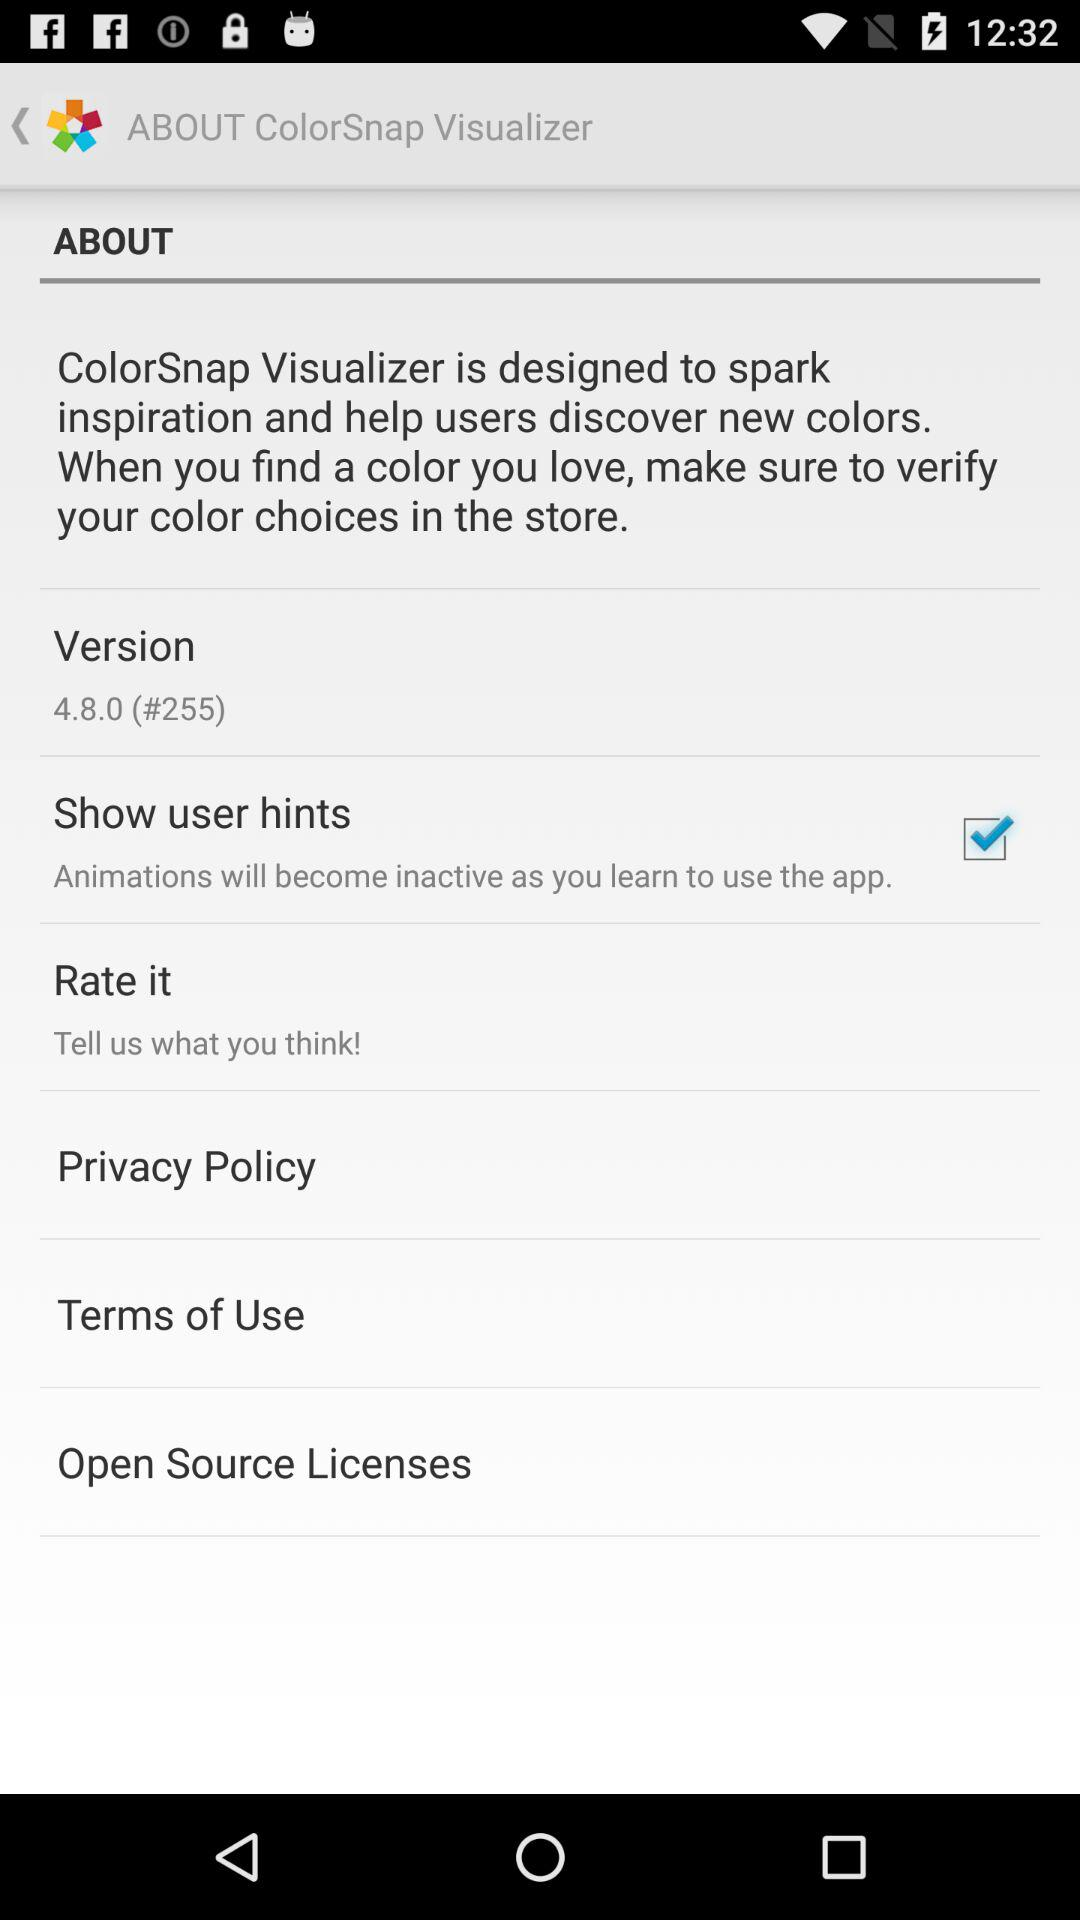What is the version used? The version used is 4.8.0. 